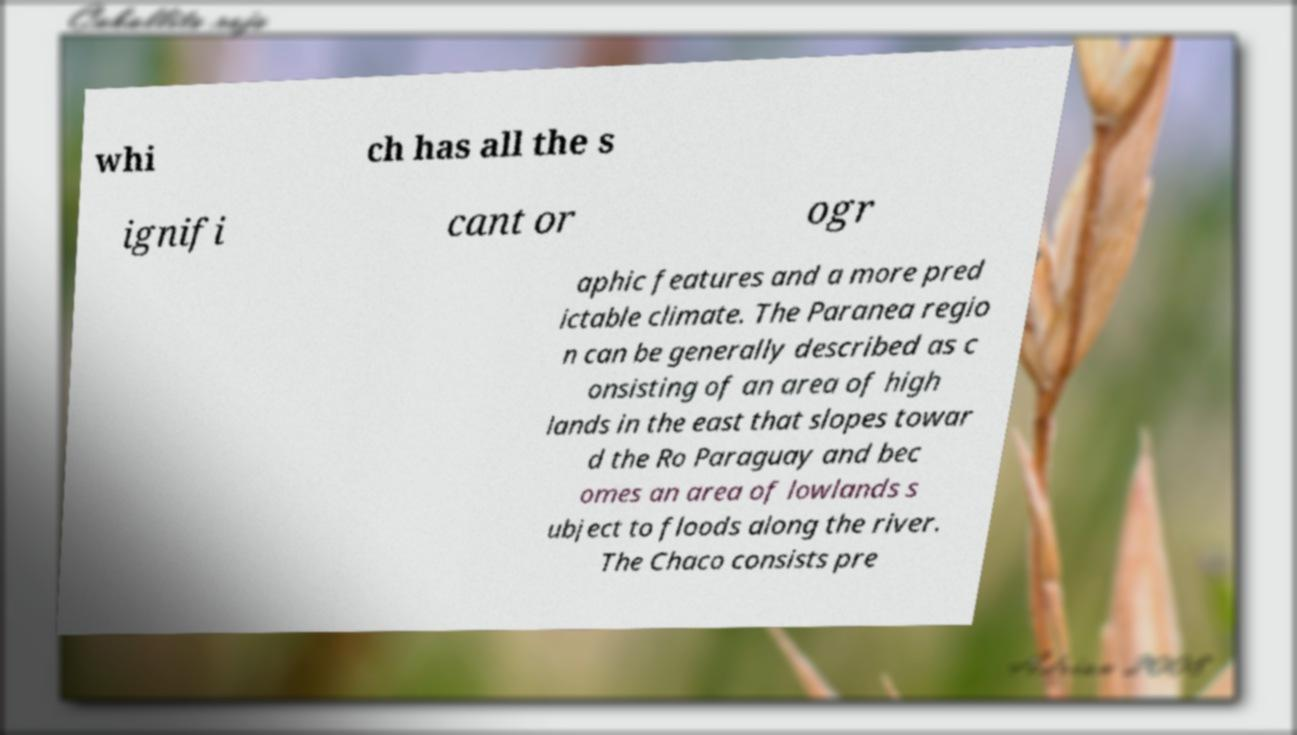Can you accurately transcribe the text from the provided image for me? whi ch has all the s ignifi cant or ogr aphic features and a more pred ictable climate. The Paranea regio n can be generally described as c onsisting of an area of high lands in the east that slopes towar d the Ro Paraguay and bec omes an area of lowlands s ubject to floods along the river. The Chaco consists pre 